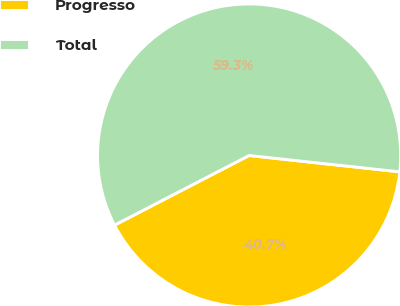Convert chart. <chart><loc_0><loc_0><loc_500><loc_500><pie_chart><fcel>Progresso<fcel>Total<nl><fcel>40.68%<fcel>59.32%<nl></chart> 